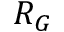<formula> <loc_0><loc_0><loc_500><loc_500>R _ { G }</formula> 